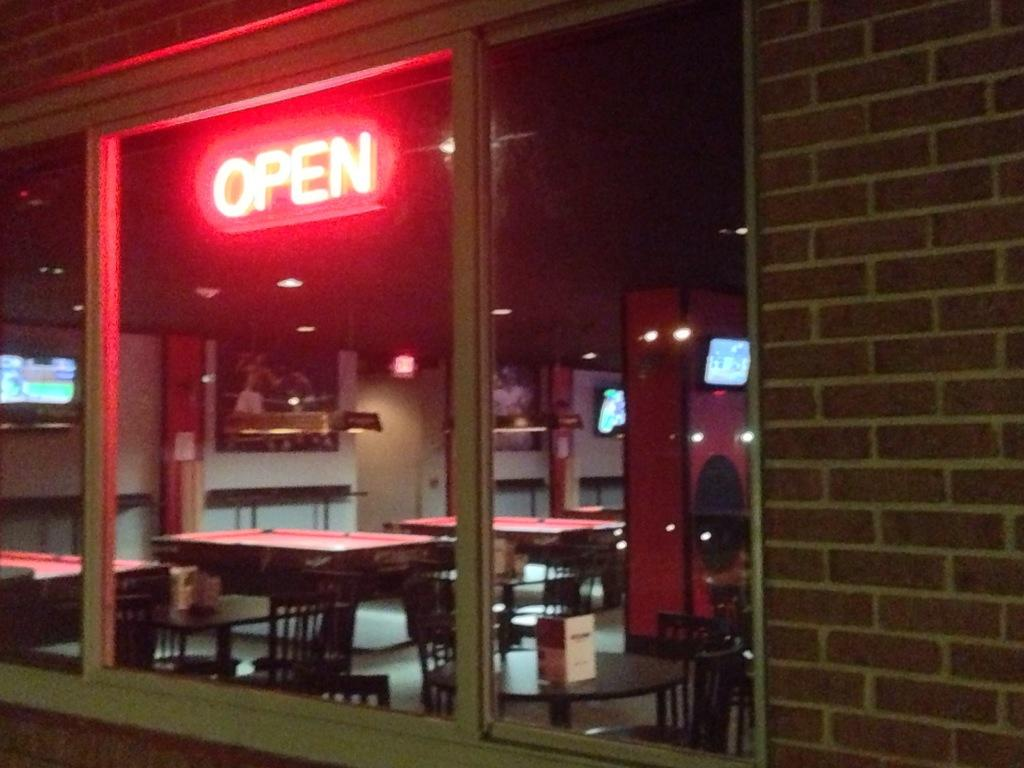What message is displayed on the board in the image? The board in the image has the word "OPEN" on it. What type of furniture is visible in the image? There are tables and chairs in the image. What can be seen on the walls in the background of the image? There are boards attached to the wall in the background of the image. What type of wax or powder is being used on the furniture in the image? There is no wax or powder being used on the furniture in the image. The tables and chairs are simply visible as they are. 